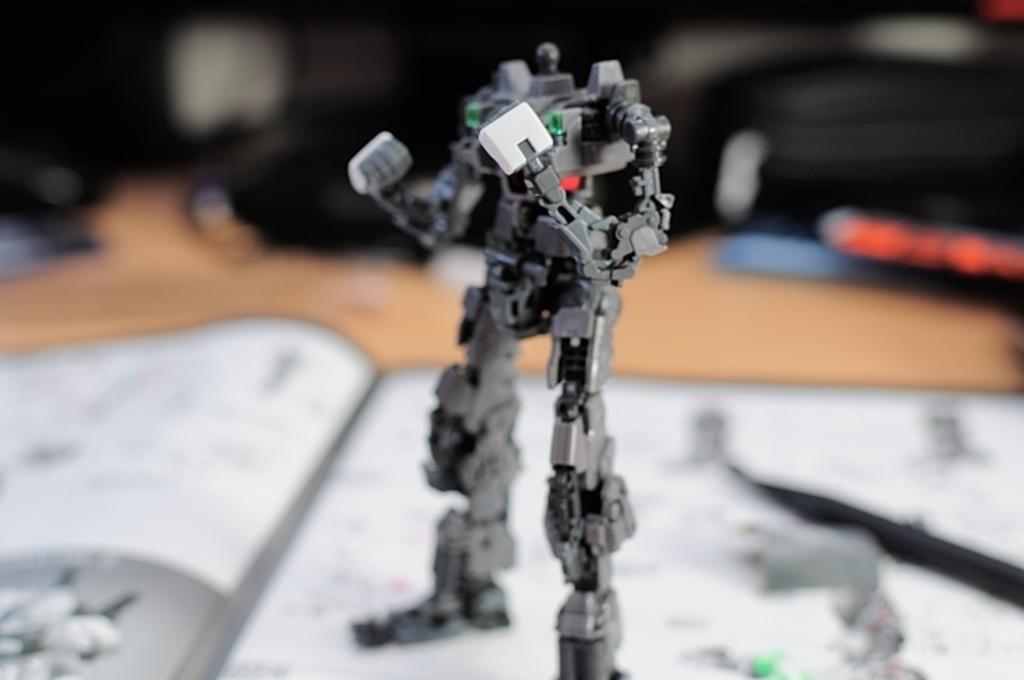Describe this image in one or two sentences. In this image I can see a black and white colour thing over here. I can also see white colour object in background and I can see this image is little bit blurry from background. 